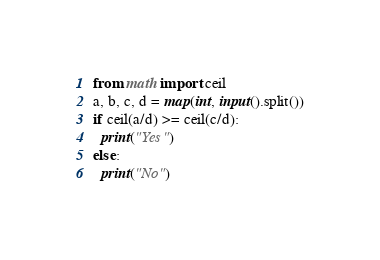Convert code to text. <code><loc_0><loc_0><loc_500><loc_500><_Python_>from math import ceil
a, b, c, d = map(int, input().split())
if ceil(a/d) >= ceil(c/d):
  print("Yes")
else:
  print("No")</code> 